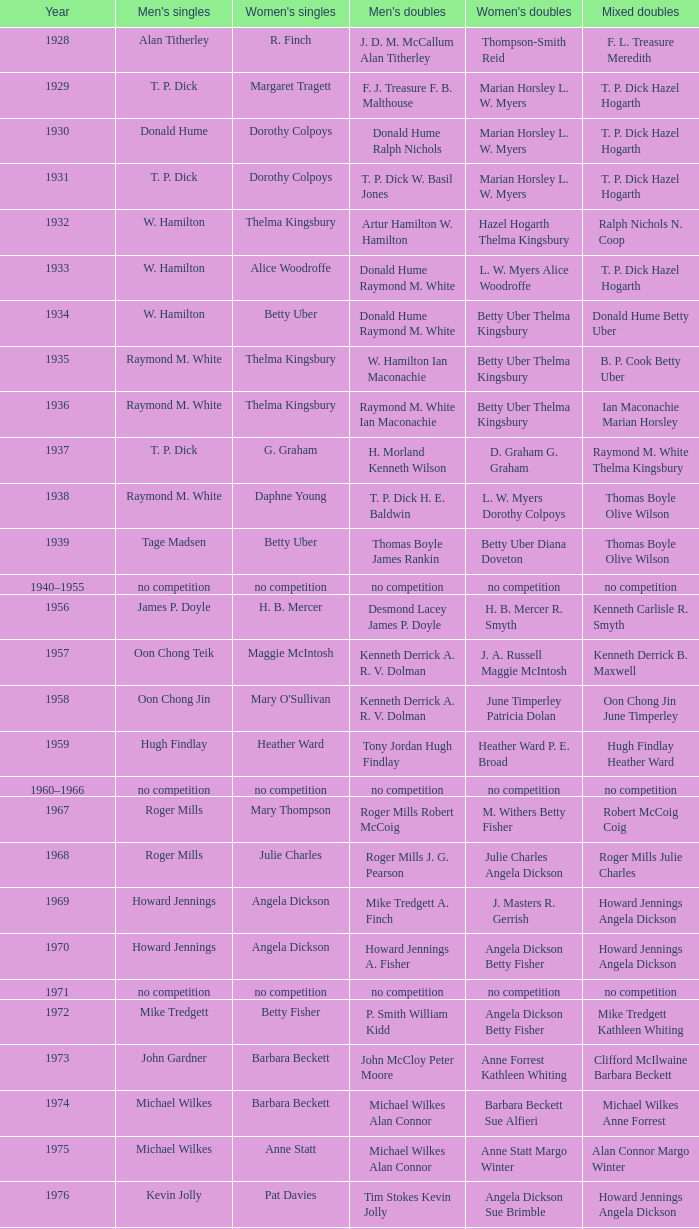When raymond m. white conquered the men's singles and w. hamilton ian maconachie claimed the men's doubles, who succeeded in winning the women's singles? Thelma Kingsbury. 